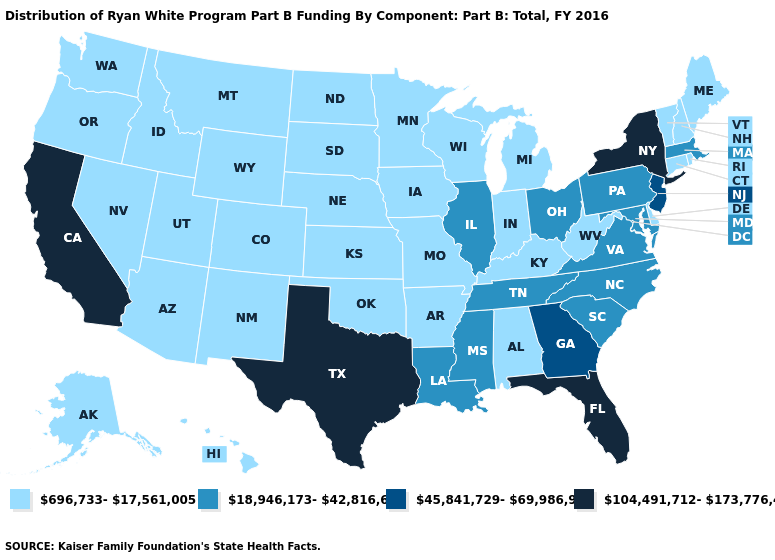What is the value of Connecticut?
Be succinct. 696,733-17,561,005. What is the highest value in the USA?
Keep it brief. 104,491,712-173,776,410. Does Illinois have the lowest value in the MidWest?
Write a very short answer. No. What is the lowest value in the Northeast?
Write a very short answer. 696,733-17,561,005. Does Georgia have a higher value than Oklahoma?
Give a very brief answer. Yes. Which states have the highest value in the USA?
Quick response, please. California, Florida, New York, Texas. Name the states that have a value in the range 45,841,729-69,986,915?
Give a very brief answer. Georgia, New Jersey. Among the states that border North Carolina , which have the lowest value?
Write a very short answer. South Carolina, Tennessee, Virginia. What is the highest value in states that border Nevada?
Give a very brief answer. 104,491,712-173,776,410. What is the value of Utah?
Keep it brief. 696,733-17,561,005. Which states have the lowest value in the USA?
Keep it brief. Alabama, Alaska, Arizona, Arkansas, Colorado, Connecticut, Delaware, Hawaii, Idaho, Indiana, Iowa, Kansas, Kentucky, Maine, Michigan, Minnesota, Missouri, Montana, Nebraska, Nevada, New Hampshire, New Mexico, North Dakota, Oklahoma, Oregon, Rhode Island, South Dakota, Utah, Vermont, Washington, West Virginia, Wisconsin, Wyoming. Which states hav the highest value in the MidWest?
Keep it brief. Illinois, Ohio. What is the highest value in states that border Nevada?
Concise answer only. 104,491,712-173,776,410. Does the first symbol in the legend represent the smallest category?
Write a very short answer. Yes. How many symbols are there in the legend?
Quick response, please. 4. 